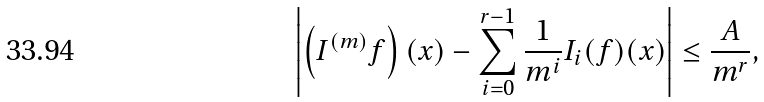<formula> <loc_0><loc_0><loc_500><loc_500>\left | \left ( I ^ { ( m ) } f \right ) ( x ) - \sum _ { i = 0 } ^ { r - 1 } \frac { 1 } { m ^ { i } } I _ { i } ( f ) ( x ) \right | \leq \frac { A } { m ^ { r } } ,</formula> 